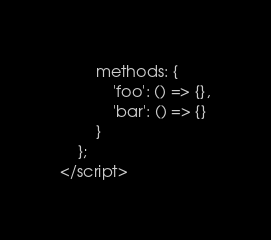Convert code to text. <code><loc_0><loc_0><loc_500><loc_500><_HTML_>		methods: {
			'foo': () => {},
			'bar': () => {}
		}
	};
</script></code> 